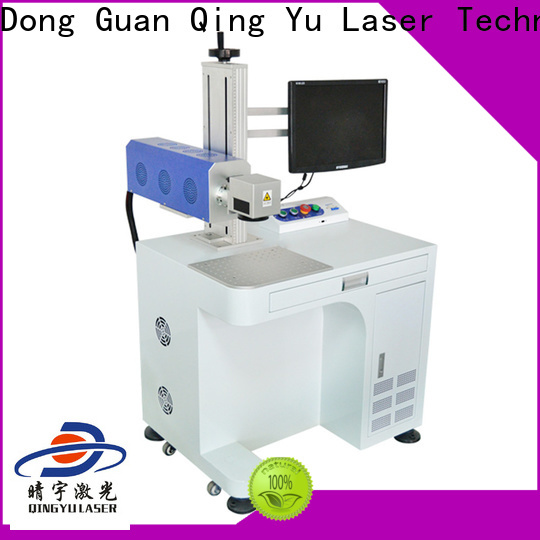What creative applications can you think of for this machine outside of traditional industrial uses? Let's get creative! Beyond traditional industrial uses, this laser engraving machine could be a tool for futuristic art and design studios. Artists could use it to engrave intricate designs on unconventional materials like ceramics, wood, or even leather, creating unique, personalized art pieces. Imagine a collaborative project between engineers and artists where the machine creates interactive, light-reactive art installations by engraving patterns that channel light in innovative ways. Additionally, it could be utilized in haute couture fashion, engraving detailed, custom patterns on luxury fabrics or accessories. Furthermore, educational institutions could employ it as a hands-on tool for STEM programs, allowing students to design and fabricate precise models or prototypes, thereby bridging creativity with technical skills. 